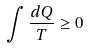Convert formula to latex. <formula><loc_0><loc_0><loc_500><loc_500>\int \frac { d Q } { T } \geq 0</formula> 